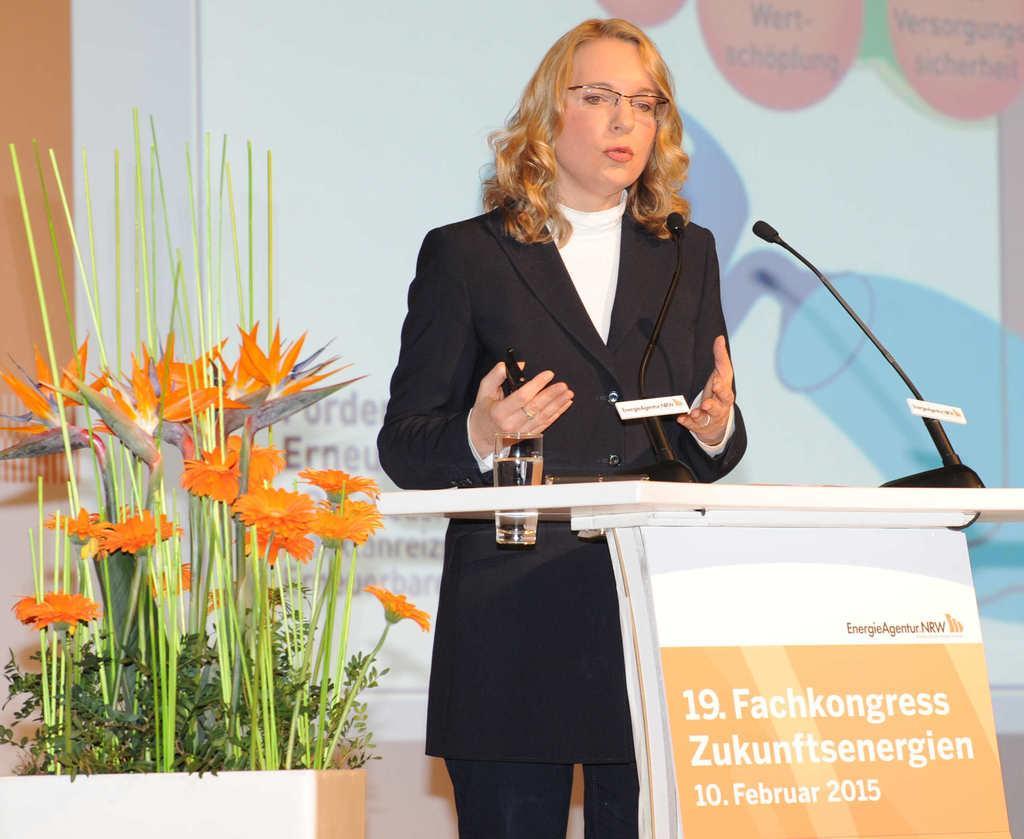Please provide a concise description of this image. In the image in the center, we can see one woman standing. In front of her, there is a stand, glass, microphone and banner. In the background we can see plants, flowers and one screen. 